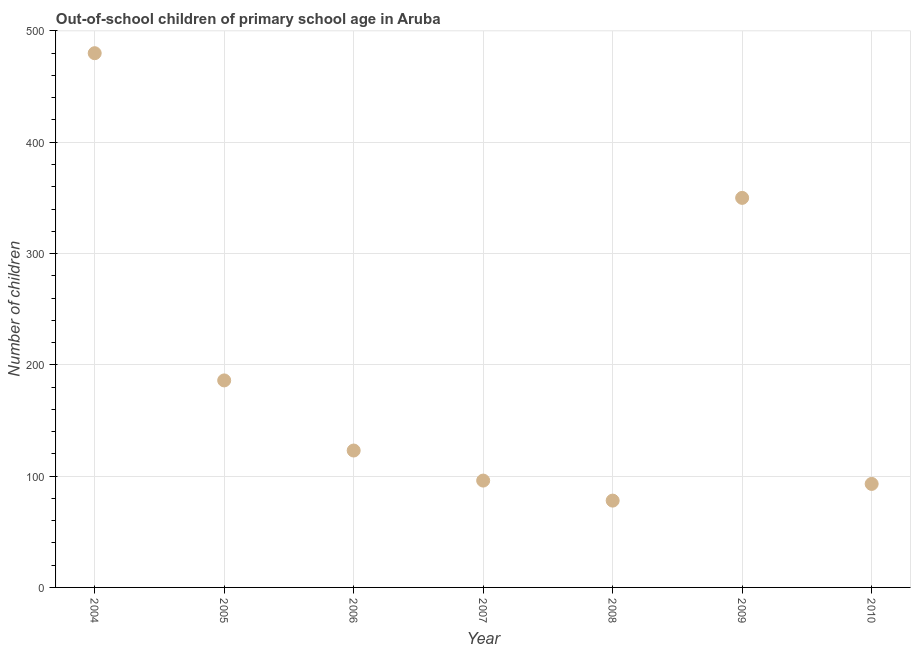What is the number of out-of-school children in 2007?
Offer a terse response. 96. Across all years, what is the maximum number of out-of-school children?
Give a very brief answer. 480. Across all years, what is the minimum number of out-of-school children?
Make the answer very short. 78. In which year was the number of out-of-school children maximum?
Give a very brief answer. 2004. In which year was the number of out-of-school children minimum?
Your response must be concise. 2008. What is the sum of the number of out-of-school children?
Make the answer very short. 1406. What is the difference between the number of out-of-school children in 2005 and 2010?
Offer a terse response. 93. What is the average number of out-of-school children per year?
Provide a succinct answer. 200.86. What is the median number of out-of-school children?
Your answer should be compact. 123. In how many years, is the number of out-of-school children greater than 400 ?
Offer a terse response. 1. What is the ratio of the number of out-of-school children in 2008 to that in 2009?
Make the answer very short. 0.22. Is the number of out-of-school children in 2004 less than that in 2010?
Provide a succinct answer. No. Is the difference between the number of out-of-school children in 2004 and 2007 greater than the difference between any two years?
Keep it short and to the point. No. What is the difference between the highest and the second highest number of out-of-school children?
Provide a short and direct response. 130. What is the difference between the highest and the lowest number of out-of-school children?
Your answer should be compact. 402. In how many years, is the number of out-of-school children greater than the average number of out-of-school children taken over all years?
Offer a very short reply. 2. Does the number of out-of-school children monotonically increase over the years?
Make the answer very short. No. How many years are there in the graph?
Your answer should be very brief. 7. Does the graph contain any zero values?
Give a very brief answer. No. Does the graph contain grids?
Ensure brevity in your answer.  Yes. What is the title of the graph?
Provide a succinct answer. Out-of-school children of primary school age in Aruba. What is the label or title of the Y-axis?
Your answer should be compact. Number of children. What is the Number of children in 2004?
Provide a succinct answer. 480. What is the Number of children in 2005?
Provide a succinct answer. 186. What is the Number of children in 2006?
Offer a very short reply. 123. What is the Number of children in 2007?
Give a very brief answer. 96. What is the Number of children in 2008?
Offer a terse response. 78. What is the Number of children in 2009?
Offer a terse response. 350. What is the Number of children in 2010?
Offer a very short reply. 93. What is the difference between the Number of children in 2004 and 2005?
Your answer should be very brief. 294. What is the difference between the Number of children in 2004 and 2006?
Your answer should be compact. 357. What is the difference between the Number of children in 2004 and 2007?
Offer a very short reply. 384. What is the difference between the Number of children in 2004 and 2008?
Offer a very short reply. 402. What is the difference between the Number of children in 2004 and 2009?
Offer a very short reply. 130. What is the difference between the Number of children in 2004 and 2010?
Give a very brief answer. 387. What is the difference between the Number of children in 2005 and 2008?
Your answer should be very brief. 108. What is the difference between the Number of children in 2005 and 2009?
Your answer should be compact. -164. What is the difference between the Number of children in 2005 and 2010?
Your answer should be compact. 93. What is the difference between the Number of children in 2006 and 2009?
Keep it short and to the point. -227. What is the difference between the Number of children in 2006 and 2010?
Ensure brevity in your answer.  30. What is the difference between the Number of children in 2007 and 2008?
Provide a succinct answer. 18. What is the difference between the Number of children in 2007 and 2009?
Keep it short and to the point. -254. What is the difference between the Number of children in 2008 and 2009?
Your answer should be compact. -272. What is the difference between the Number of children in 2009 and 2010?
Give a very brief answer. 257. What is the ratio of the Number of children in 2004 to that in 2005?
Ensure brevity in your answer.  2.58. What is the ratio of the Number of children in 2004 to that in 2006?
Provide a short and direct response. 3.9. What is the ratio of the Number of children in 2004 to that in 2007?
Ensure brevity in your answer.  5. What is the ratio of the Number of children in 2004 to that in 2008?
Your answer should be very brief. 6.15. What is the ratio of the Number of children in 2004 to that in 2009?
Offer a terse response. 1.37. What is the ratio of the Number of children in 2004 to that in 2010?
Ensure brevity in your answer.  5.16. What is the ratio of the Number of children in 2005 to that in 2006?
Provide a succinct answer. 1.51. What is the ratio of the Number of children in 2005 to that in 2007?
Your answer should be compact. 1.94. What is the ratio of the Number of children in 2005 to that in 2008?
Your response must be concise. 2.38. What is the ratio of the Number of children in 2005 to that in 2009?
Make the answer very short. 0.53. What is the ratio of the Number of children in 2005 to that in 2010?
Make the answer very short. 2. What is the ratio of the Number of children in 2006 to that in 2007?
Your response must be concise. 1.28. What is the ratio of the Number of children in 2006 to that in 2008?
Keep it short and to the point. 1.58. What is the ratio of the Number of children in 2006 to that in 2009?
Provide a succinct answer. 0.35. What is the ratio of the Number of children in 2006 to that in 2010?
Provide a short and direct response. 1.32. What is the ratio of the Number of children in 2007 to that in 2008?
Make the answer very short. 1.23. What is the ratio of the Number of children in 2007 to that in 2009?
Your response must be concise. 0.27. What is the ratio of the Number of children in 2007 to that in 2010?
Offer a terse response. 1.03. What is the ratio of the Number of children in 2008 to that in 2009?
Your response must be concise. 0.22. What is the ratio of the Number of children in 2008 to that in 2010?
Ensure brevity in your answer.  0.84. What is the ratio of the Number of children in 2009 to that in 2010?
Offer a very short reply. 3.76. 